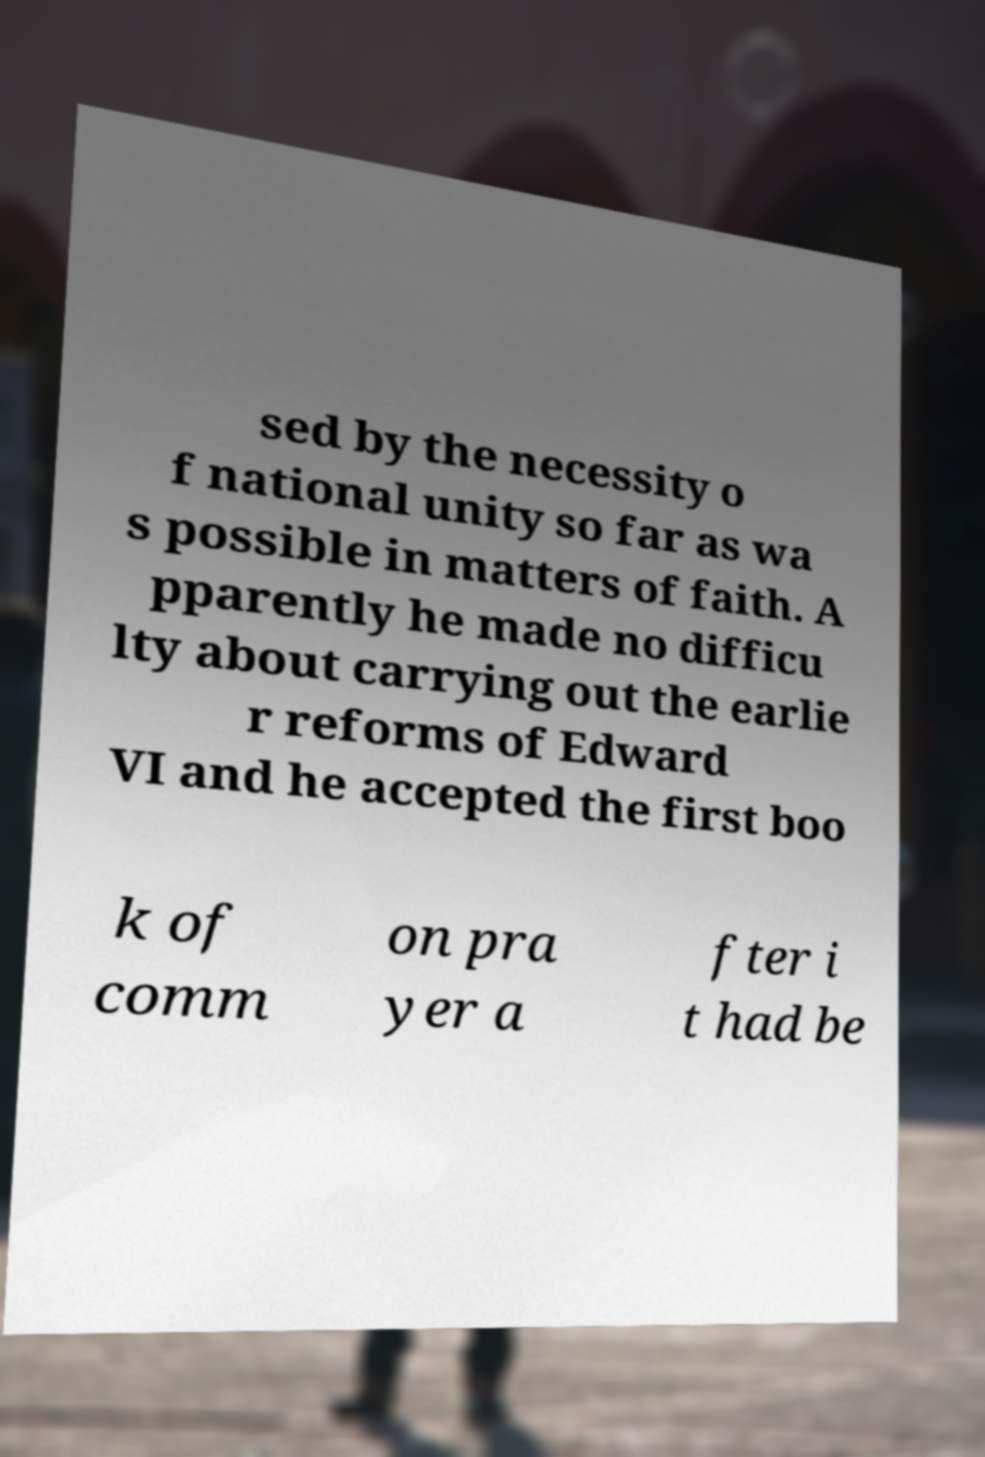What messages or text are displayed in this image? I need them in a readable, typed format. sed by the necessity o f national unity so far as wa s possible in matters of faith. A pparently he made no difficu lty about carrying out the earlie r reforms of Edward VI and he accepted the first boo k of comm on pra yer a fter i t had be 